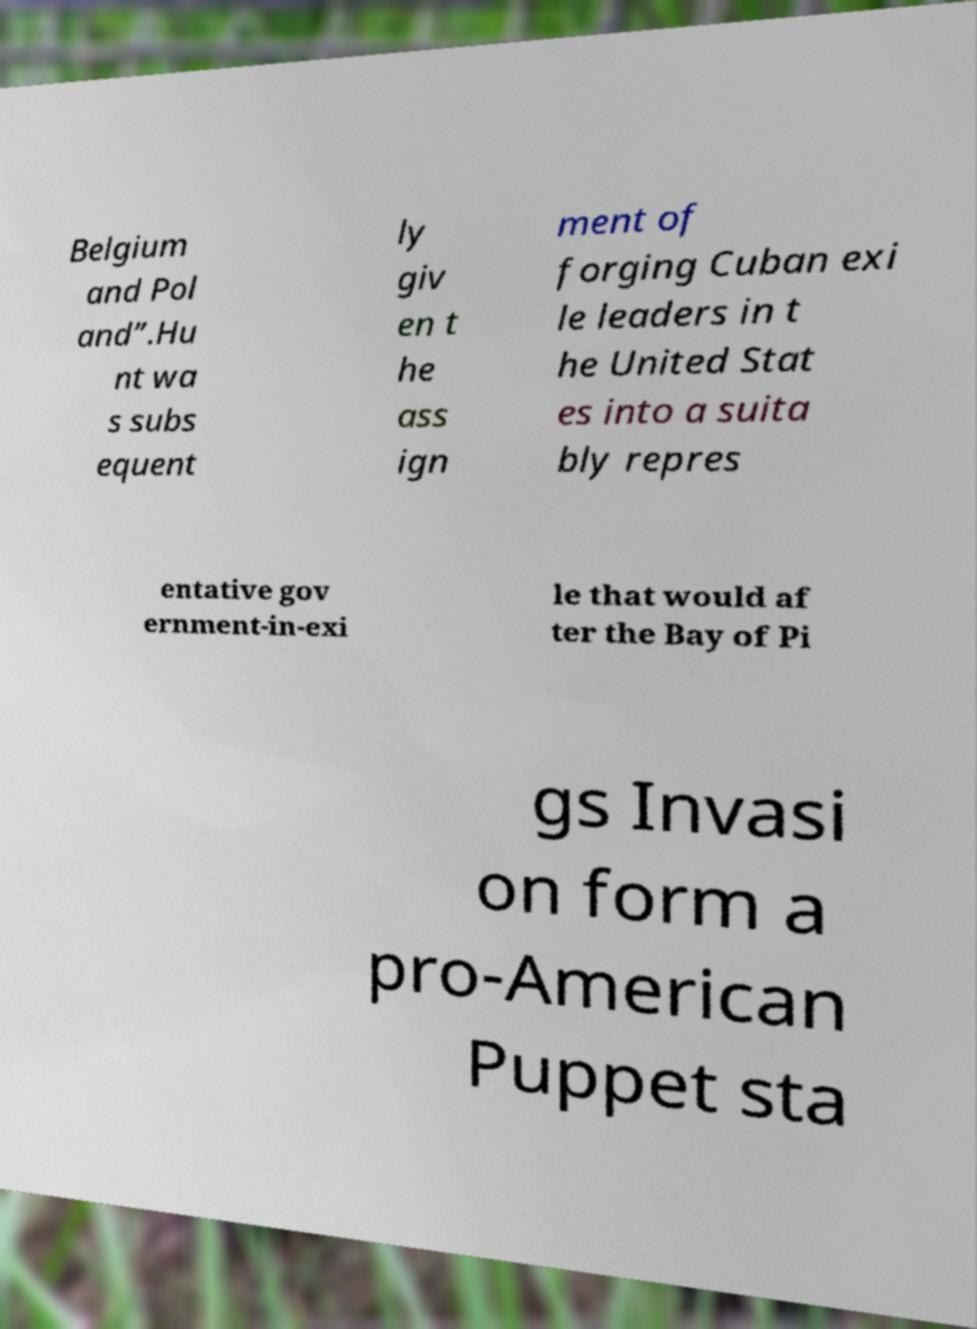Please identify and transcribe the text found in this image. Belgium and Pol and”.Hu nt wa s subs equent ly giv en t he ass ign ment of forging Cuban exi le leaders in t he United Stat es into a suita bly repres entative gov ernment-in-exi le that would af ter the Bay of Pi gs Invasi on form a pro-American Puppet sta 